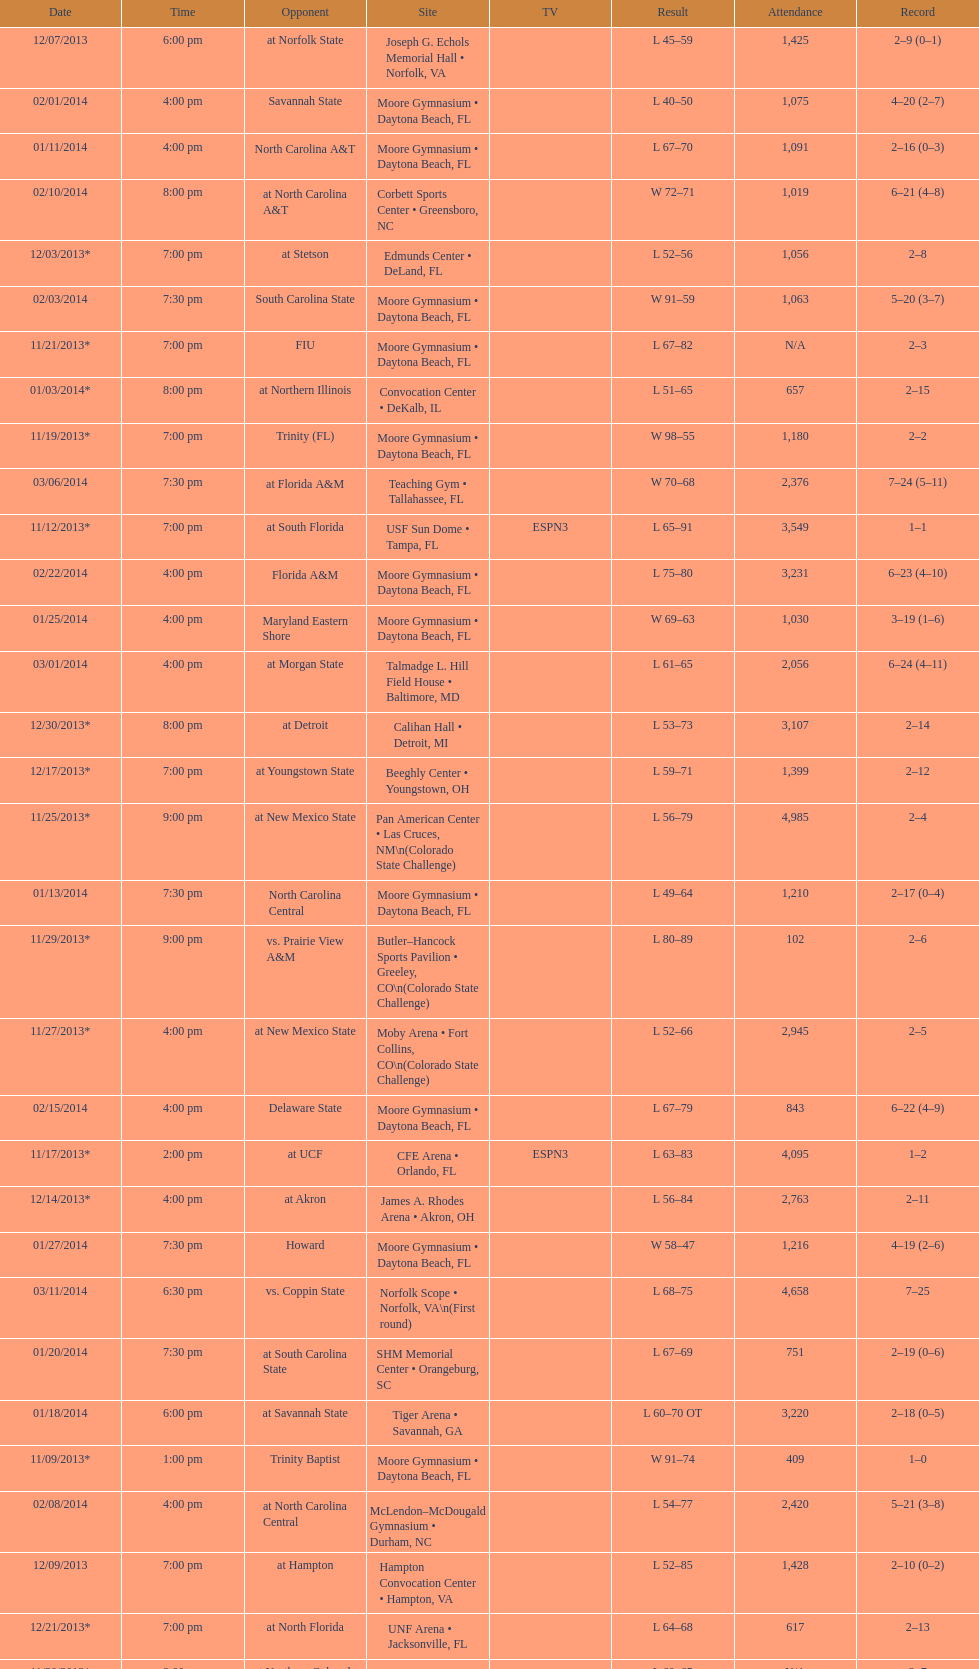Was the attendance of the game held on 11/19/2013 greater than 1,000? Yes. 